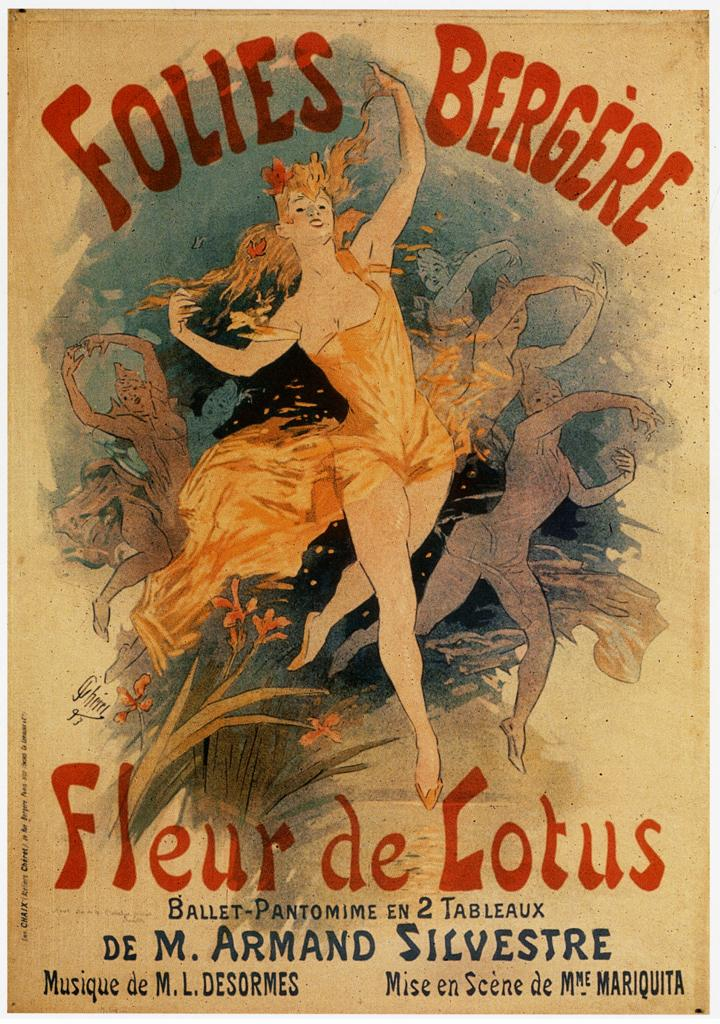<image>
Write a terse but informative summary of the picture. a Fleur de Lotus sign has a person dancing on it 